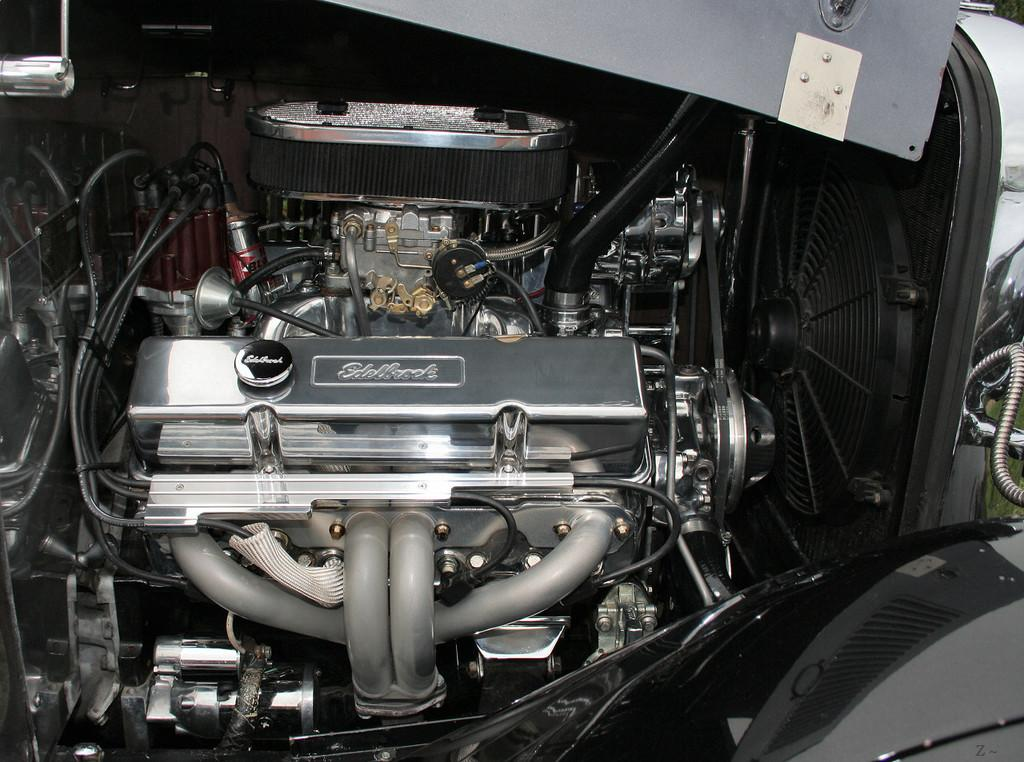What is the main subject of the image? The main subject of the image is the engine of a vehicle. What can be seen in addition to the engine? There are plenty of wires visible in the image. Can you describe the engine in more detail? There are various other parts of the engine visible in the image. What type of plants can be seen growing on the mountain in the image? There is no mountain or plants present in the image; it depicts the engine of a vehicle. What discovery was made by the explorer in the image? There is no explorer or discovery present in the image; it depicts the engine of a vehicle. 